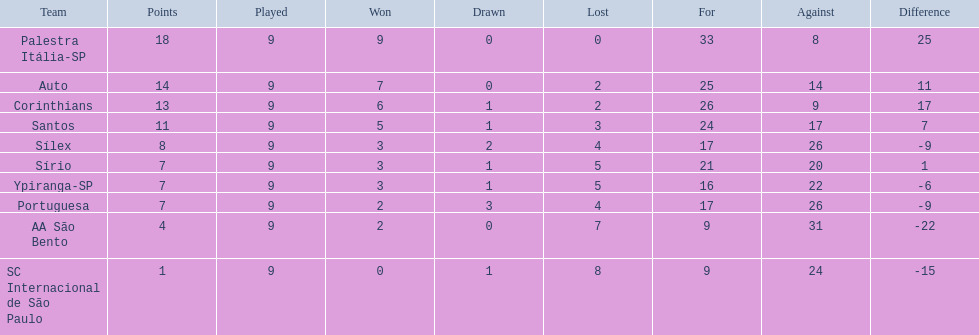What teams played in 1926? Palestra Itália-SP, Auto, Corinthians, Santos, Sílex, Sírio, Ypiranga-SP, Portuguesa, AA São Bento, SC Internacional de São Paulo. Did any team lose zero games? Palestra Itália-SP. 